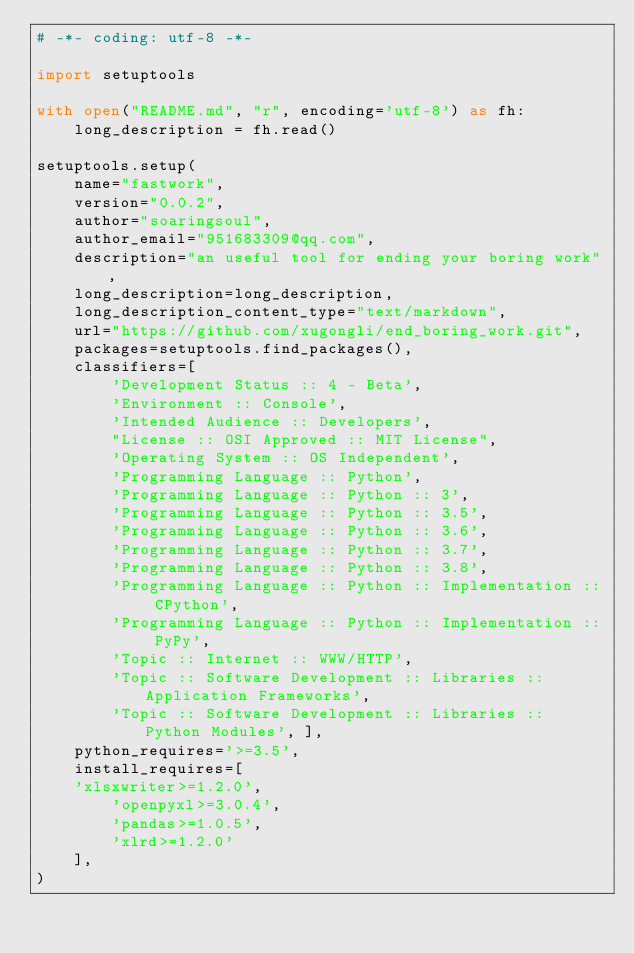<code> <loc_0><loc_0><loc_500><loc_500><_Python_># -*- coding: utf-8 -*-

import setuptools

with open("README.md", "r", encoding='utf-8') as fh:
    long_description = fh.read()

setuptools.setup(
    name="fastwork",
    version="0.0.2",
    author="soaringsoul",
    author_email="951683309@qq.com",
    description="an useful tool for ending your boring work",
    long_description=long_description,
    long_description_content_type="text/markdown",
    url="https://github.com/xugongli/end_boring_work.git",
    packages=setuptools.find_packages(),
    classifiers=[
        'Development Status :: 4 - Beta',
        'Environment :: Console',
        'Intended Audience :: Developers',
        "License :: OSI Approved :: MIT License",
        'Operating System :: OS Independent',
        'Programming Language :: Python',
        'Programming Language :: Python :: 3',
        'Programming Language :: Python :: 3.5',
        'Programming Language :: Python :: 3.6',
        'Programming Language :: Python :: 3.7',
        'Programming Language :: Python :: 3.8',
        'Programming Language :: Python :: Implementation :: CPython',
        'Programming Language :: Python :: Implementation :: PyPy',
        'Topic :: Internet :: WWW/HTTP',
        'Topic :: Software Development :: Libraries :: Application Frameworks',
        'Topic :: Software Development :: Libraries :: Python Modules', ],
    python_requires='>=3.5',
    install_requires=[
		'xlsxwriter>=1.2.0',
        'openpyxl>=3.0.4',
        'pandas>=1.0.5',
        'xlrd>=1.2.0'
    ],
)
</code> 